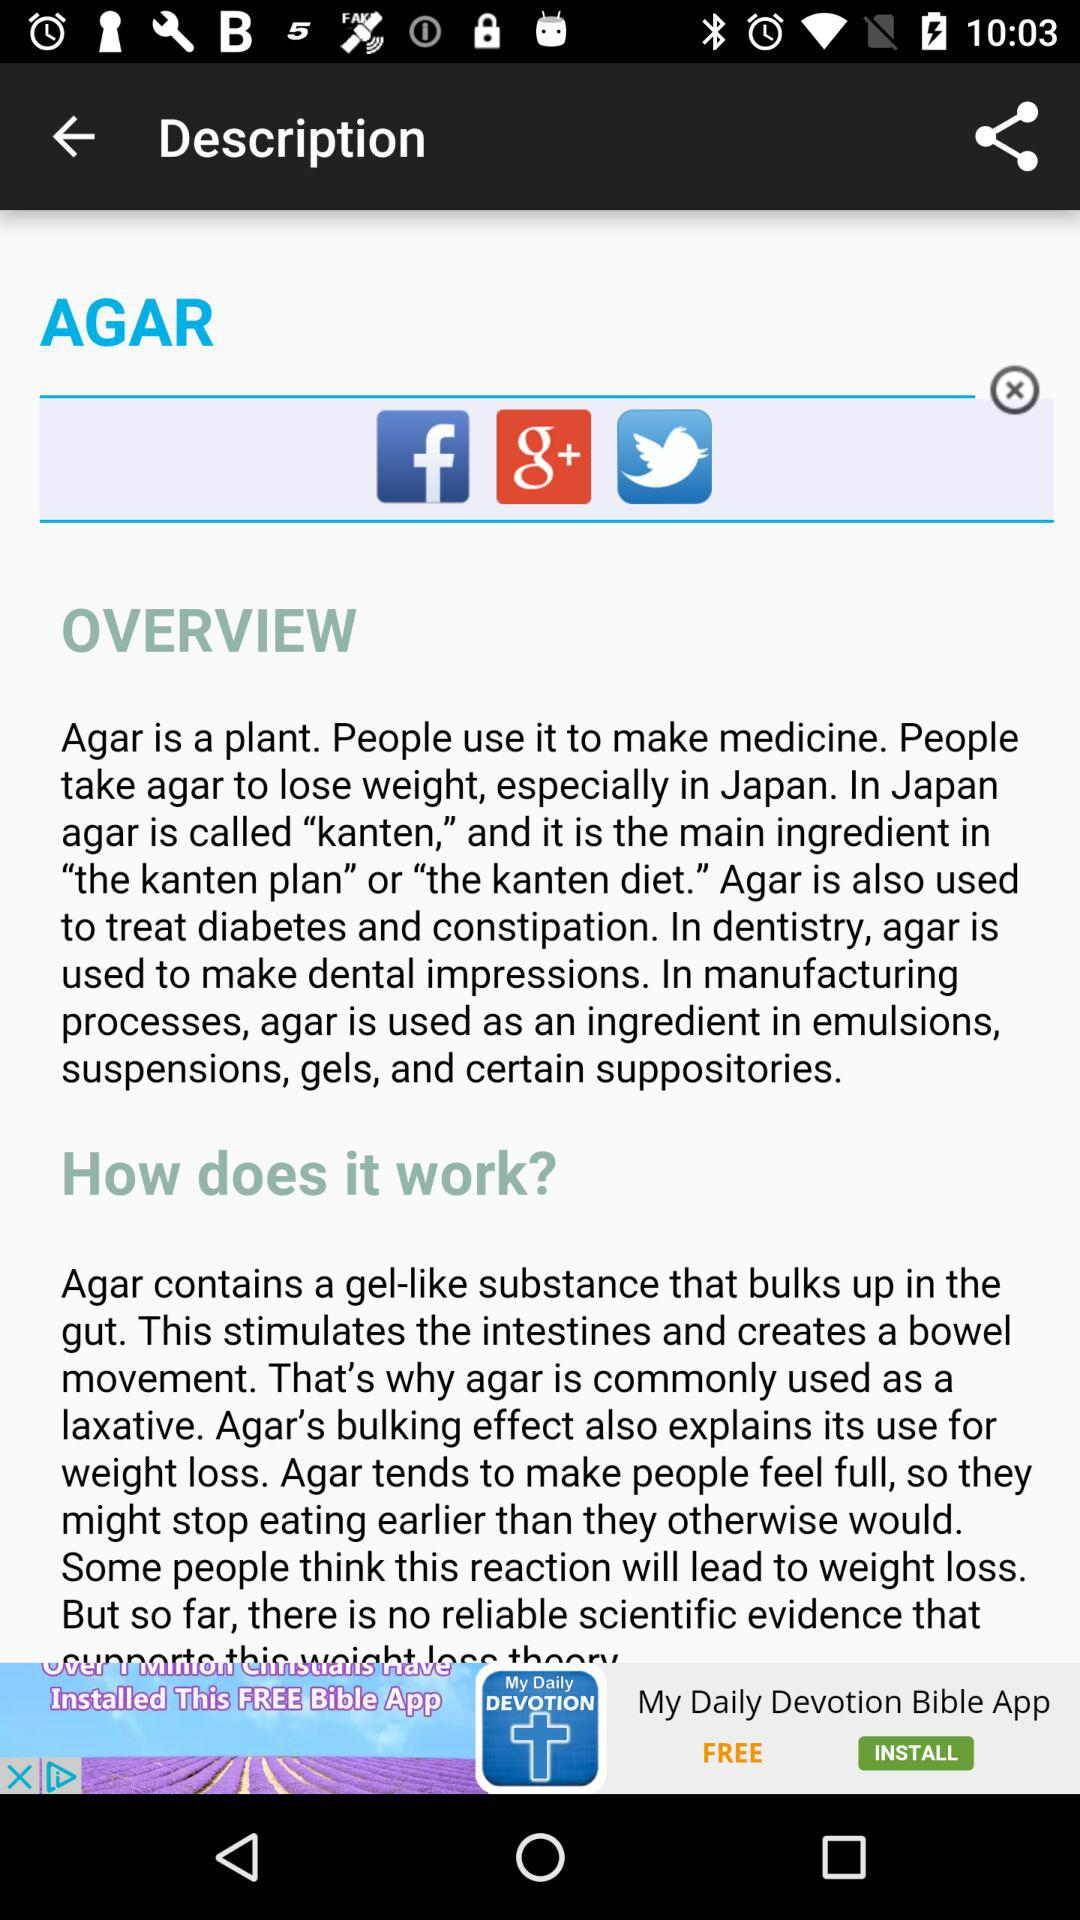What is agar? Agar is a plant. 